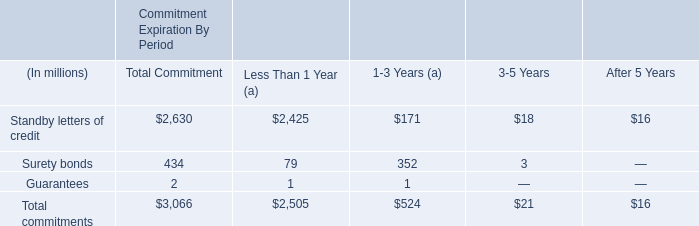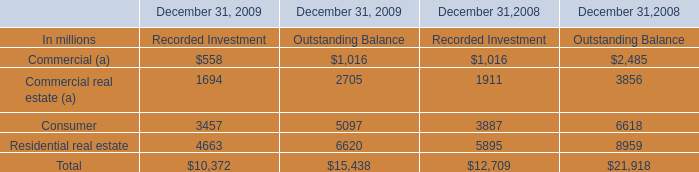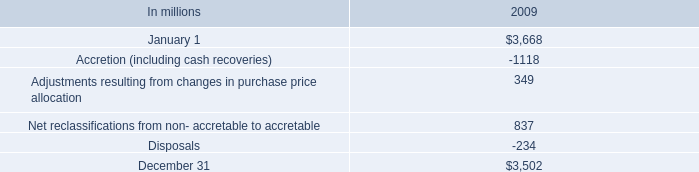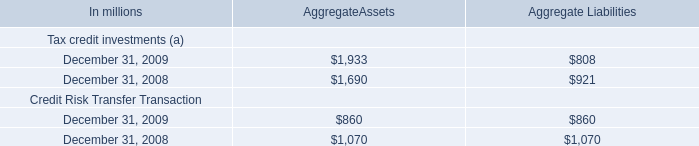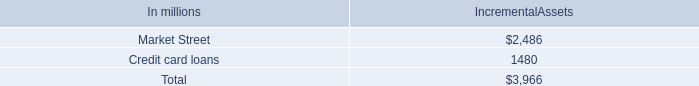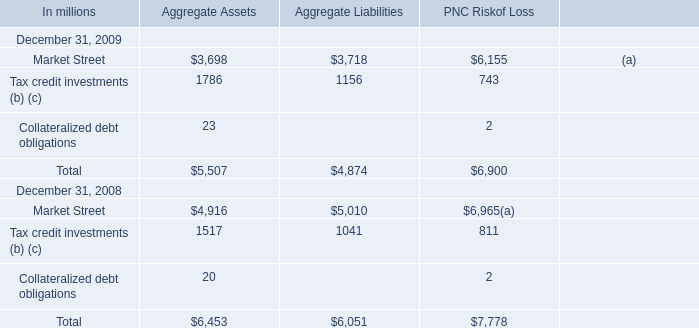In the year with the greatest proportion of Tax credit investments (b) (c) for Aggregate Assetswhat is the proportion of Tax credit investments (b) (c)to the tatal? 
Computations: (1517 / (((4916 + 1517) + 20) + 6453))
Answer: 0.11754. 